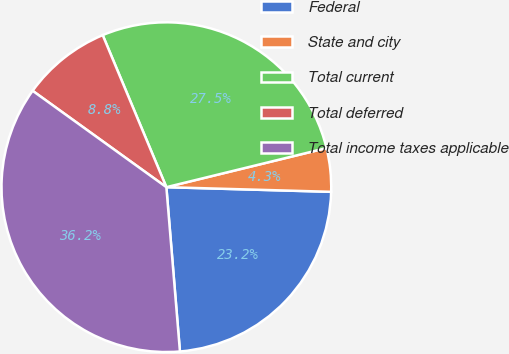Convert chart. <chart><loc_0><loc_0><loc_500><loc_500><pie_chart><fcel>Federal<fcel>State and city<fcel>Total current<fcel>Total deferred<fcel>Total income taxes applicable<nl><fcel>23.24%<fcel>4.26%<fcel>27.5%<fcel>8.75%<fcel>36.25%<nl></chart> 